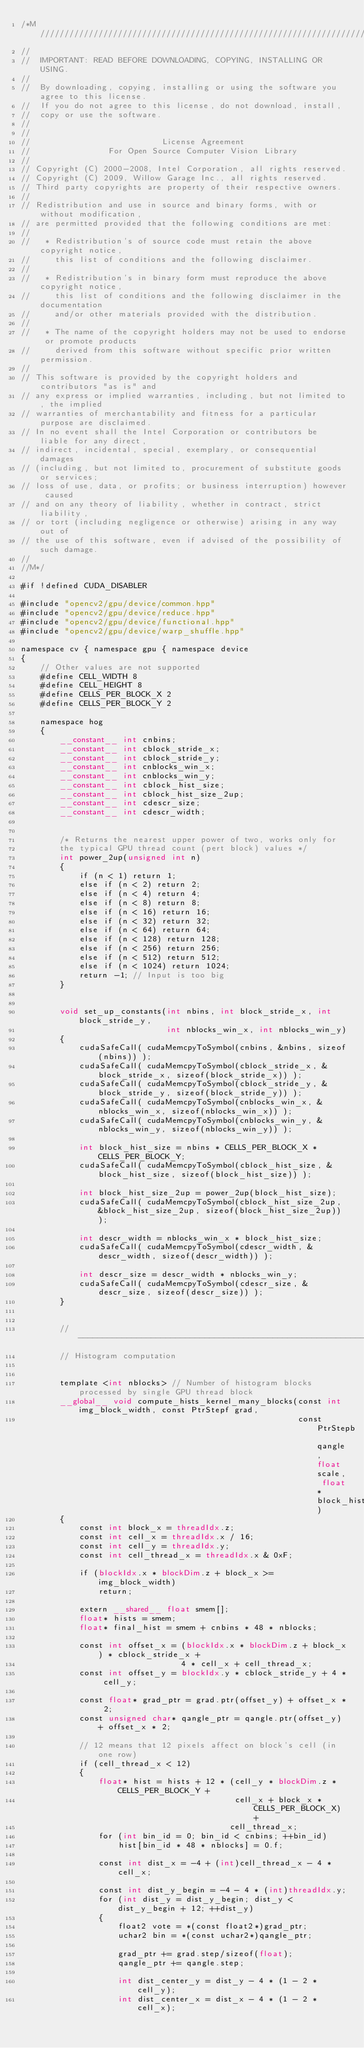<code> <loc_0><loc_0><loc_500><loc_500><_Cuda_>/*M///////////////////////////////////////////////////////////////////////////////////////
//
//  IMPORTANT: READ BEFORE DOWNLOADING, COPYING, INSTALLING OR USING.
//
//  By downloading, copying, installing or using the software you agree to this license.
//  If you do not agree to this license, do not download, install,
//  copy or use the software.
//
//
//                           License Agreement
//                For Open Source Computer Vision Library
//
// Copyright (C) 2000-2008, Intel Corporation, all rights reserved.
// Copyright (C) 2009, Willow Garage Inc., all rights reserved.
// Third party copyrights are property of their respective owners.
//
// Redistribution and use in source and binary forms, with or without modification,
// are permitted provided that the following conditions are met:
//
//   * Redistribution's of source code must retain the above copyright notice,
//     this list of conditions and the following disclaimer.
//
//   * Redistribution's in binary form must reproduce the above copyright notice,
//     this list of conditions and the following disclaimer in the documentation
//     and/or other materials provided with the distribution.
//
//   * The name of the copyright holders may not be used to endorse or promote products
//     derived from this software without specific prior written permission.
//
// This software is provided by the copyright holders and contributors "as is" and
// any express or implied warranties, including, but not limited to, the implied
// warranties of merchantability and fitness for a particular purpose are disclaimed.
// In no event shall the Intel Corporation or contributors be liable for any direct,
// indirect, incidental, special, exemplary, or consequential damages
// (including, but not limited to, procurement of substitute goods or services;
// loss of use, data, or profits; or business interruption) however caused
// and on any theory of liability, whether in contract, strict liability,
// or tort (including negligence or otherwise) arising in any way out of
// the use of this software, even if advised of the possibility of such damage.
//
//M*/

#if !defined CUDA_DISABLER

#include "opencv2/gpu/device/common.hpp"
#include "opencv2/gpu/device/reduce.hpp"
#include "opencv2/gpu/device/functional.hpp"
#include "opencv2/gpu/device/warp_shuffle.hpp"

namespace cv { namespace gpu { namespace device
{
    // Other values are not supported
    #define CELL_WIDTH 8
    #define CELL_HEIGHT 8
    #define CELLS_PER_BLOCK_X 2
    #define CELLS_PER_BLOCK_Y 2

    namespace hog
    {
        __constant__ int cnbins;
        __constant__ int cblock_stride_x;
        __constant__ int cblock_stride_y;
        __constant__ int cnblocks_win_x;
        __constant__ int cnblocks_win_y;
        __constant__ int cblock_hist_size;
        __constant__ int cblock_hist_size_2up;
        __constant__ int cdescr_size;
        __constant__ int cdescr_width;


        /* Returns the nearest upper power of two, works only for
        the typical GPU thread count (pert block) values */
        int power_2up(unsigned int n)
        {
            if (n < 1) return 1;
            else if (n < 2) return 2;
            else if (n < 4) return 4;
            else if (n < 8) return 8;
            else if (n < 16) return 16;
            else if (n < 32) return 32;
            else if (n < 64) return 64;
            else if (n < 128) return 128;
            else if (n < 256) return 256;
            else if (n < 512) return 512;
            else if (n < 1024) return 1024;
            return -1; // Input is too big
        }


        void set_up_constants(int nbins, int block_stride_x, int block_stride_y,
                              int nblocks_win_x, int nblocks_win_y)
        {
            cudaSafeCall( cudaMemcpyToSymbol(cnbins, &nbins, sizeof(nbins)) );
            cudaSafeCall( cudaMemcpyToSymbol(cblock_stride_x, &block_stride_x, sizeof(block_stride_x)) );
            cudaSafeCall( cudaMemcpyToSymbol(cblock_stride_y, &block_stride_y, sizeof(block_stride_y)) );
            cudaSafeCall( cudaMemcpyToSymbol(cnblocks_win_x, &nblocks_win_x, sizeof(nblocks_win_x)) );
            cudaSafeCall( cudaMemcpyToSymbol(cnblocks_win_y, &nblocks_win_y, sizeof(nblocks_win_y)) );

            int block_hist_size = nbins * CELLS_PER_BLOCK_X * CELLS_PER_BLOCK_Y;
            cudaSafeCall( cudaMemcpyToSymbol(cblock_hist_size, &block_hist_size, sizeof(block_hist_size)) );

            int block_hist_size_2up = power_2up(block_hist_size);
            cudaSafeCall( cudaMemcpyToSymbol(cblock_hist_size_2up, &block_hist_size_2up, sizeof(block_hist_size_2up)) );

            int descr_width = nblocks_win_x * block_hist_size;
            cudaSafeCall( cudaMemcpyToSymbol(cdescr_width, &descr_width, sizeof(descr_width)) );

            int descr_size = descr_width * nblocks_win_y;
            cudaSafeCall( cudaMemcpyToSymbol(cdescr_size, &descr_size, sizeof(descr_size)) );
        }


        //----------------------------------------------------------------------------
        // Histogram computation


        template <int nblocks> // Number of histogram blocks processed by single GPU thread block
        __global__ void compute_hists_kernel_many_blocks(const int img_block_width, const PtrStepf grad,
                                                         const PtrStepb qangle, float scale, float* block_hists)
        {
            const int block_x = threadIdx.z;
            const int cell_x = threadIdx.x / 16;
            const int cell_y = threadIdx.y;
            const int cell_thread_x = threadIdx.x & 0xF;

            if (blockIdx.x * blockDim.z + block_x >= img_block_width)
                return;

            extern __shared__ float smem[];
            float* hists = smem;
            float* final_hist = smem + cnbins * 48 * nblocks;

            const int offset_x = (blockIdx.x * blockDim.z + block_x) * cblock_stride_x +
                                 4 * cell_x + cell_thread_x;
            const int offset_y = blockIdx.y * cblock_stride_y + 4 * cell_y;

            const float* grad_ptr = grad.ptr(offset_y) + offset_x * 2;
            const unsigned char* qangle_ptr = qangle.ptr(offset_y) + offset_x * 2;

            // 12 means that 12 pixels affect on block's cell (in one row)
            if (cell_thread_x < 12)
            {
                float* hist = hists + 12 * (cell_y * blockDim.z * CELLS_PER_BLOCK_Y +
                                            cell_x + block_x * CELLS_PER_BLOCK_X) +
                                           cell_thread_x;
                for (int bin_id = 0; bin_id < cnbins; ++bin_id)
                    hist[bin_id * 48 * nblocks] = 0.f;

                const int dist_x = -4 + (int)cell_thread_x - 4 * cell_x;

                const int dist_y_begin = -4 - 4 * (int)threadIdx.y;
                for (int dist_y = dist_y_begin; dist_y < dist_y_begin + 12; ++dist_y)
                {
                    float2 vote = *(const float2*)grad_ptr;
                    uchar2 bin = *(const uchar2*)qangle_ptr;

                    grad_ptr += grad.step/sizeof(float);
                    qangle_ptr += qangle.step;

                    int dist_center_y = dist_y - 4 * (1 - 2 * cell_y);
                    int dist_center_x = dist_x - 4 * (1 - 2 * cell_x);
</code> 